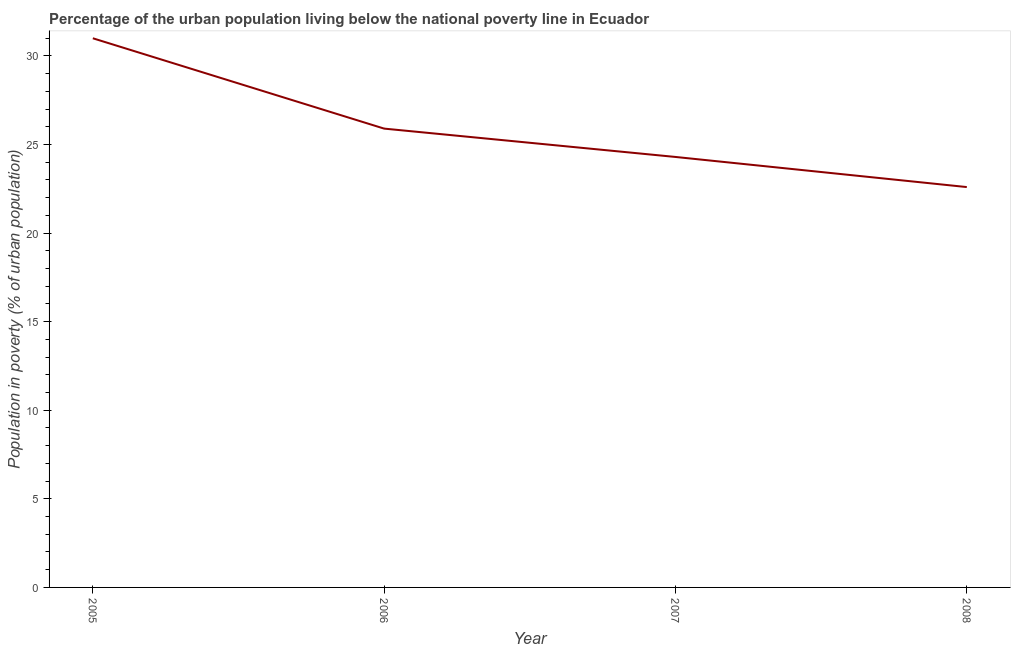Across all years, what is the minimum percentage of urban population living below poverty line?
Provide a succinct answer. 22.6. What is the sum of the percentage of urban population living below poverty line?
Your answer should be compact. 103.8. What is the difference between the percentage of urban population living below poverty line in 2005 and 2008?
Ensure brevity in your answer.  8.4. What is the average percentage of urban population living below poverty line per year?
Your response must be concise. 25.95. What is the median percentage of urban population living below poverty line?
Give a very brief answer. 25.1. In how many years, is the percentage of urban population living below poverty line greater than 12 %?
Keep it short and to the point. 4. What is the ratio of the percentage of urban population living below poverty line in 2005 to that in 2008?
Offer a terse response. 1.37. Is the percentage of urban population living below poverty line in 2006 less than that in 2008?
Make the answer very short. No. What is the difference between the highest and the second highest percentage of urban population living below poverty line?
Give a very brief answer. 5.1. What is the difference between the highest and the lowest percentage of urban population living below poverty line?
Keep it short and to the point. 8.4. Does the percentage of urban population living below poverty line monotonically increase over the years?
Offer a terse response. No. How many lines are there?
Your answer should be compact. 1. How many years are there in the graph?
Your response must be concise. 4. What is the difference between two consecutive major ticks on the Y-axis?
Offer a terse response. 5. Does the graph contain any zero values?
Your response must be concise. No. Does the graph contain grids?
Offer a very short reply. No. What is the title of the graph?
Ensure brevity in your answer.  Percentage of the urban population living below the national poverty line in Ecuador. What is the label or title of the Y-axis?
Your answer should be very brief. Population in poverty (% of urban population). What is the Population in poverty (% of urban population) of 2006?
Provide a succinct answer. 25.9. What is the Population in poverty (% of urban population) in 2007?
Offer a terse response. 24.3. What is the Population in poverty (% of urban population) in 2008?
Ensure brevity in your answer.  22.6. What is the difference between the Population in poverty (% of urban population) in 2005 and 2006?
Provide a short and direct response. 5.1. What is the ratio of the Population in poverty (% of urban population) in 2005 to that in 2006?
Keep it short and to the point. 1.2. What is the ratio of the Population in poverty (% of urban population) in 2005 to that in 2007?
Provide a short and direct response. 1.28. What is the ratio of the Population in poverty (% of urban population) in 2005 to that in 2008?
Your answer should be compact. 1.37. What is the ratio of the Population in poverty (% of urban population) in 2006 to that in 2007?
Make the answer very short. 1.07. What is the ratio of the Population in poverty (% of urban population) in 2006 to that in 2008?
Give a very brief answer. 1.15. What is the ratio of the Population in poverty (% of urban population) in 2007 to that in 2008?
Offer a terse response. 1.07. 